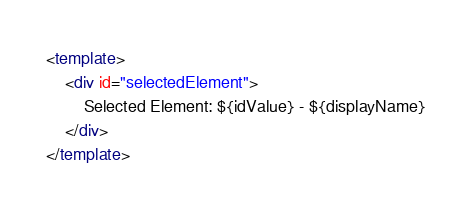<code> <loc_0><loc_0><loc_500><loc_500><_HTML_><template>
    <div id="selectedElement">
        Selected Element: ${idValue} - ${displayName}
    </div>
</template></code> 